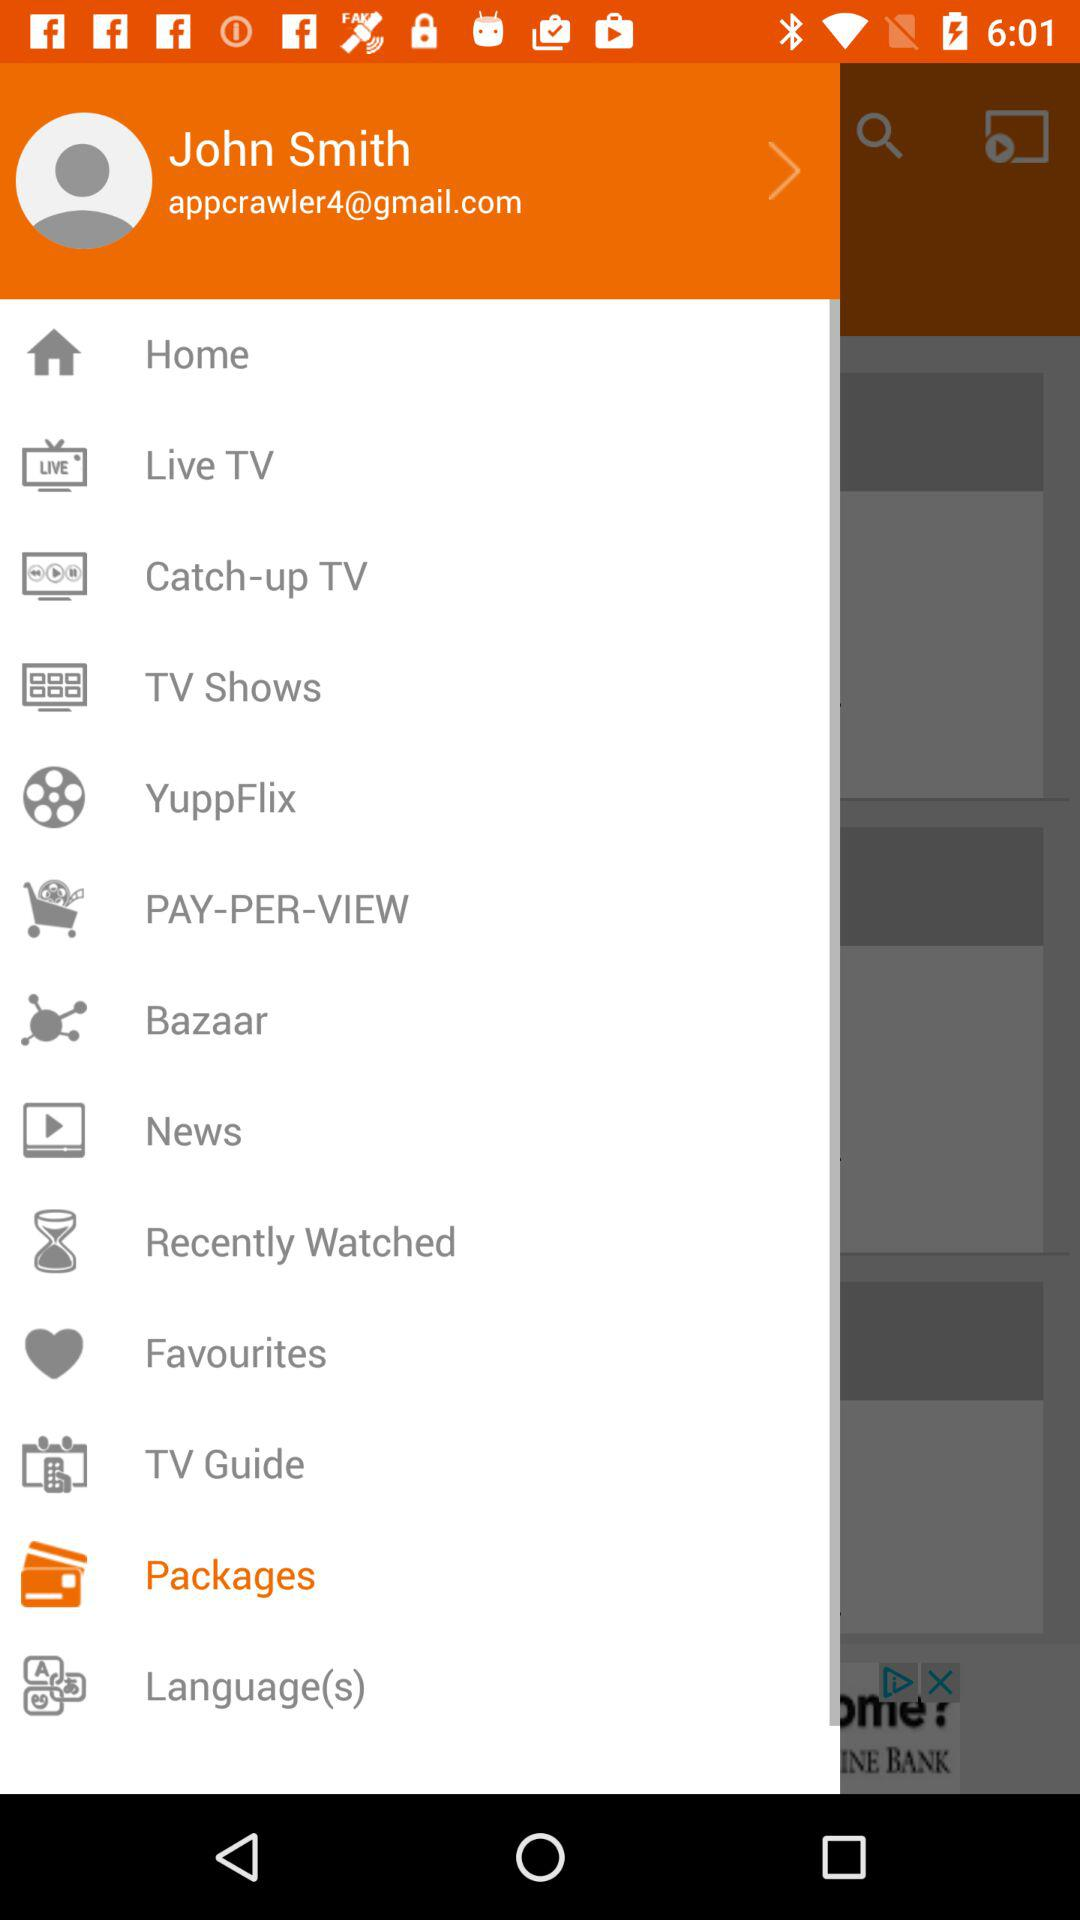What's the selected menu item? The selected menu item is "Packages". 